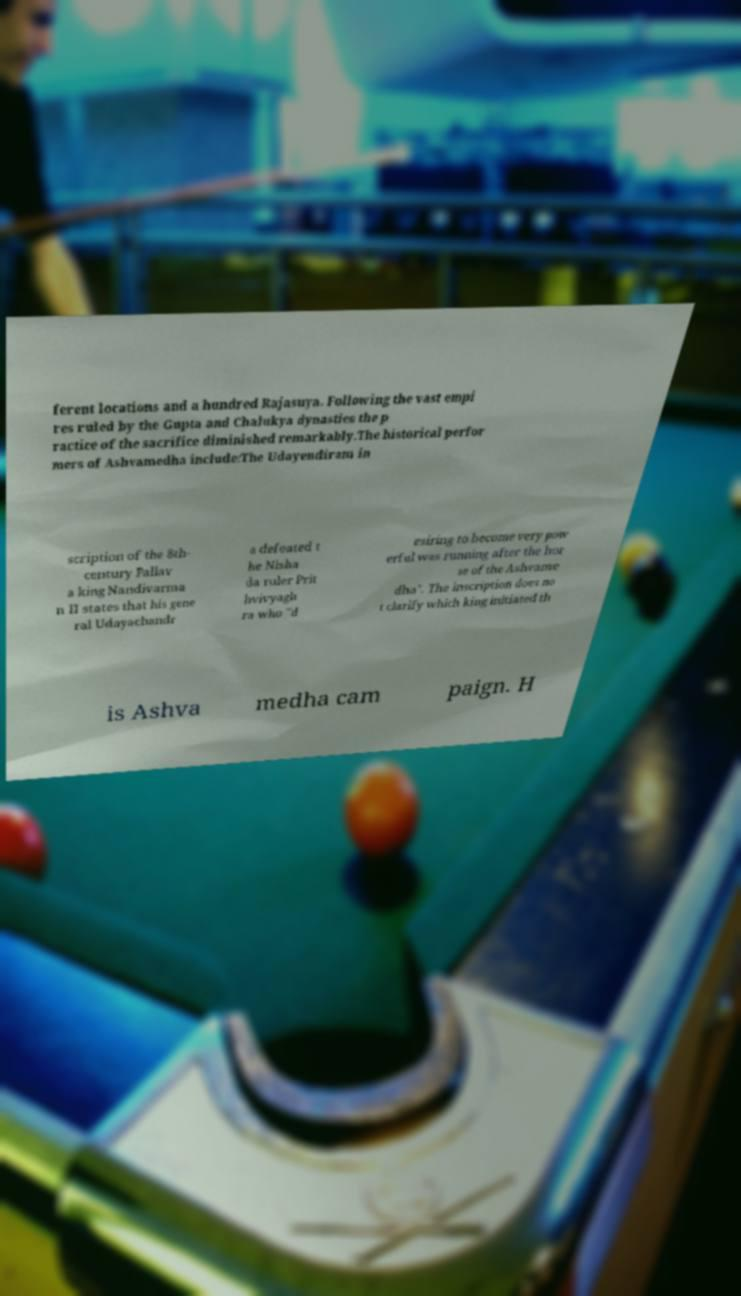Can you accurately transcribe the text from the provided image for me? ferent locations and a hundred Rajasuya. Following the vast empi res ruled by the Gupta and Chalukya dynasties the p ractice of the sacrifice diminished remarkably.The historical perfor mers of Ashvamedha include:The Udayendiram in scription of the 8th- century Pallav a king Nandivarma n II states that his gene ral Udayachandr a defeated t he Nisha da ruler Prit hvivyagh ra who "d esiring to become very pow erful was running after the hor se of the Ashvame dha". The inscription does no t clarify which king initiated th is Ashva medha cam paign. H 